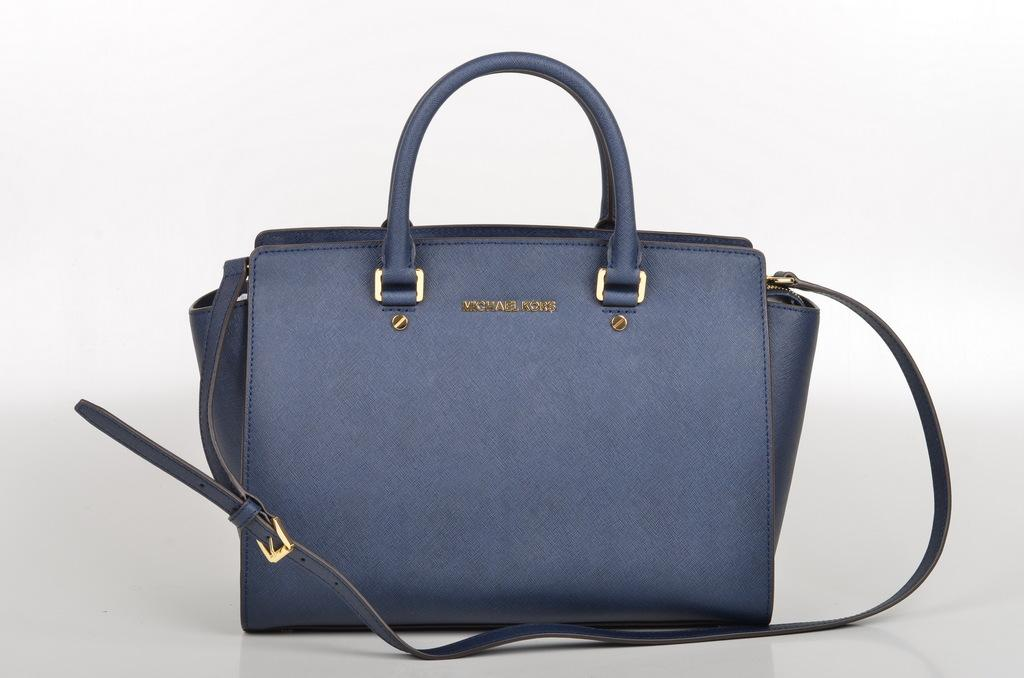What object can be seen in the image? There is a bag in the image. What is the color of the bag? The bag is blue in color. What scientific discovery is depicted on the calendar in the image? There is no calendar present in the image, so it is not possible to answer that question. 